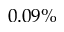<formula> <loc_0><loc_0><loc_500><loc_500>0 . 0 9 \%</formula> 